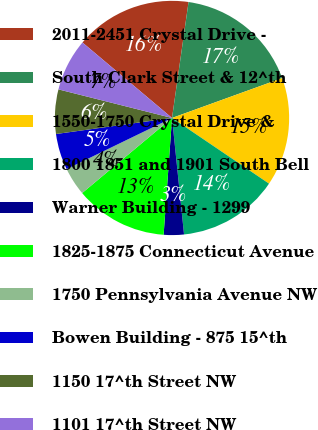<chart> <loc_0><loc_0><loc_500><loc_500><pie_chart><fcel>2011-2451 Crystal Drive -<fcel>South Clark Street & 12^th<fcel>1550-1750 Crystal Drive &<fcel>1800 1851 and 1901 South Bell<fcel>Warner Building - 1299<fcel>1825-1875 Connecticut Avenue<fcel>1750 Pennsylvania Avenue NW<fcel>Bowen Building - 875 15^th<fcel>1150 17^th Street NW<fcel>1101 17^th Street NW<nl><fcel>16.11%<fcel>17.22%<fcel>15.0%<fcel>13.89%<fcel>2.78%<fcel>12.78%<fcel>3.89%<fcel>5.0%<fcel>6.11%<fcel>7.22%<nl></chart> 